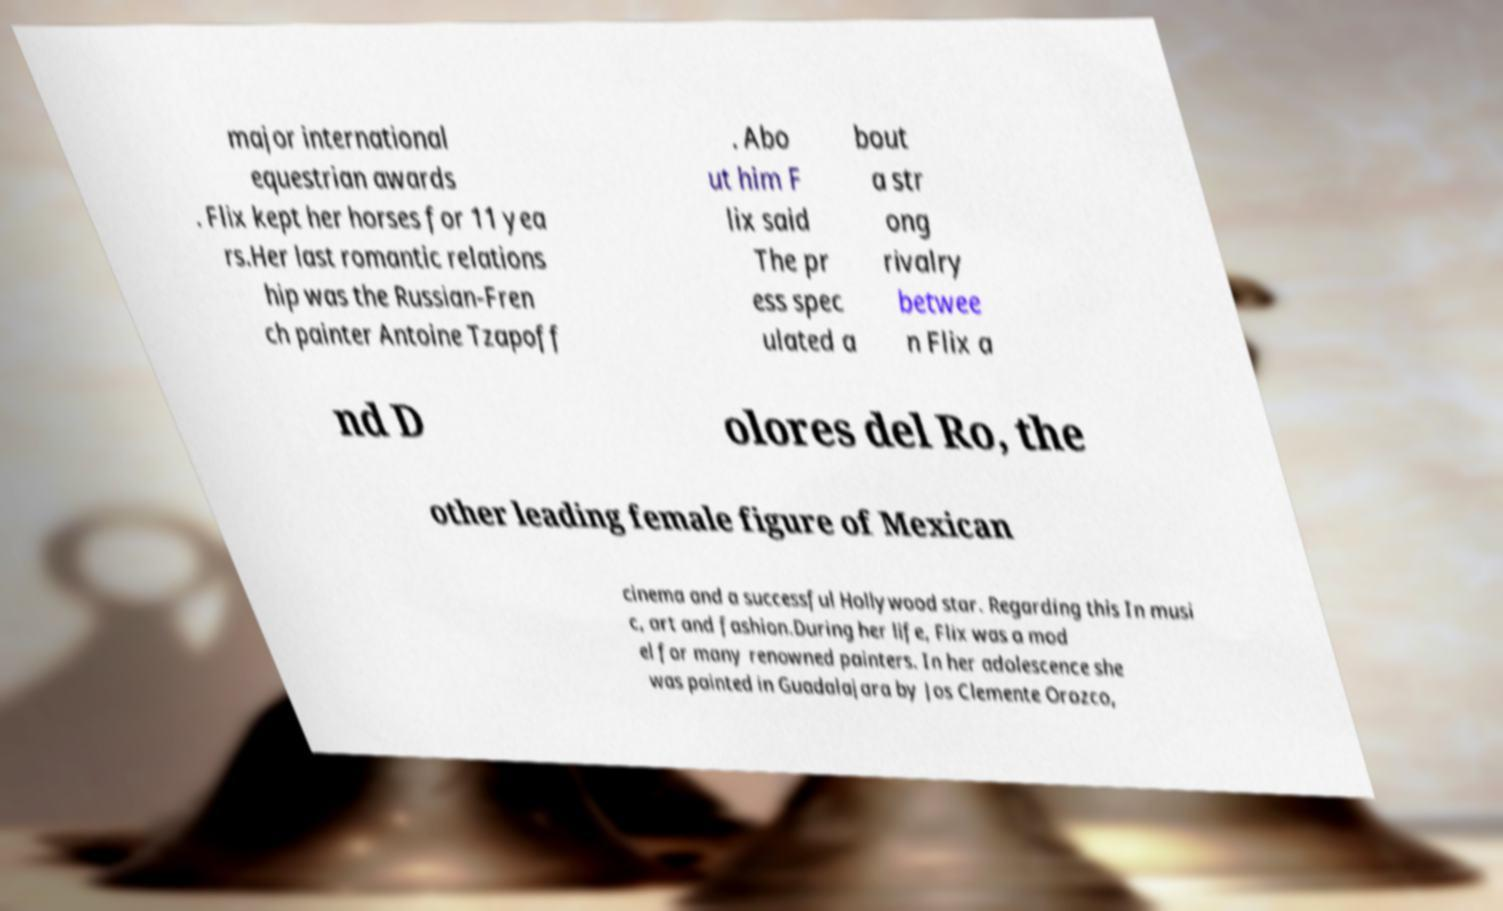What messages or text are displayed in this image? I need them in a readable, typed format. major international equestrian awards . Flix kept her horses for 11 yea rs.Her last romantic relations hip was the Russian-Fren ch painter Antoine Tzapoff . Abo ut him F lix said The pr ess spec ulated a bout a str ong rivalry betwee n Flix a nd D olores del Ro, the other leading female figure of Mexican cinema and a successful Hollywood star. Regarding this In musi c, art and fashion.During her life, Flix was a mod el for many renowned painters. In her adolescence she was painted in Guadalajara by Jos Clemente Orozco, 